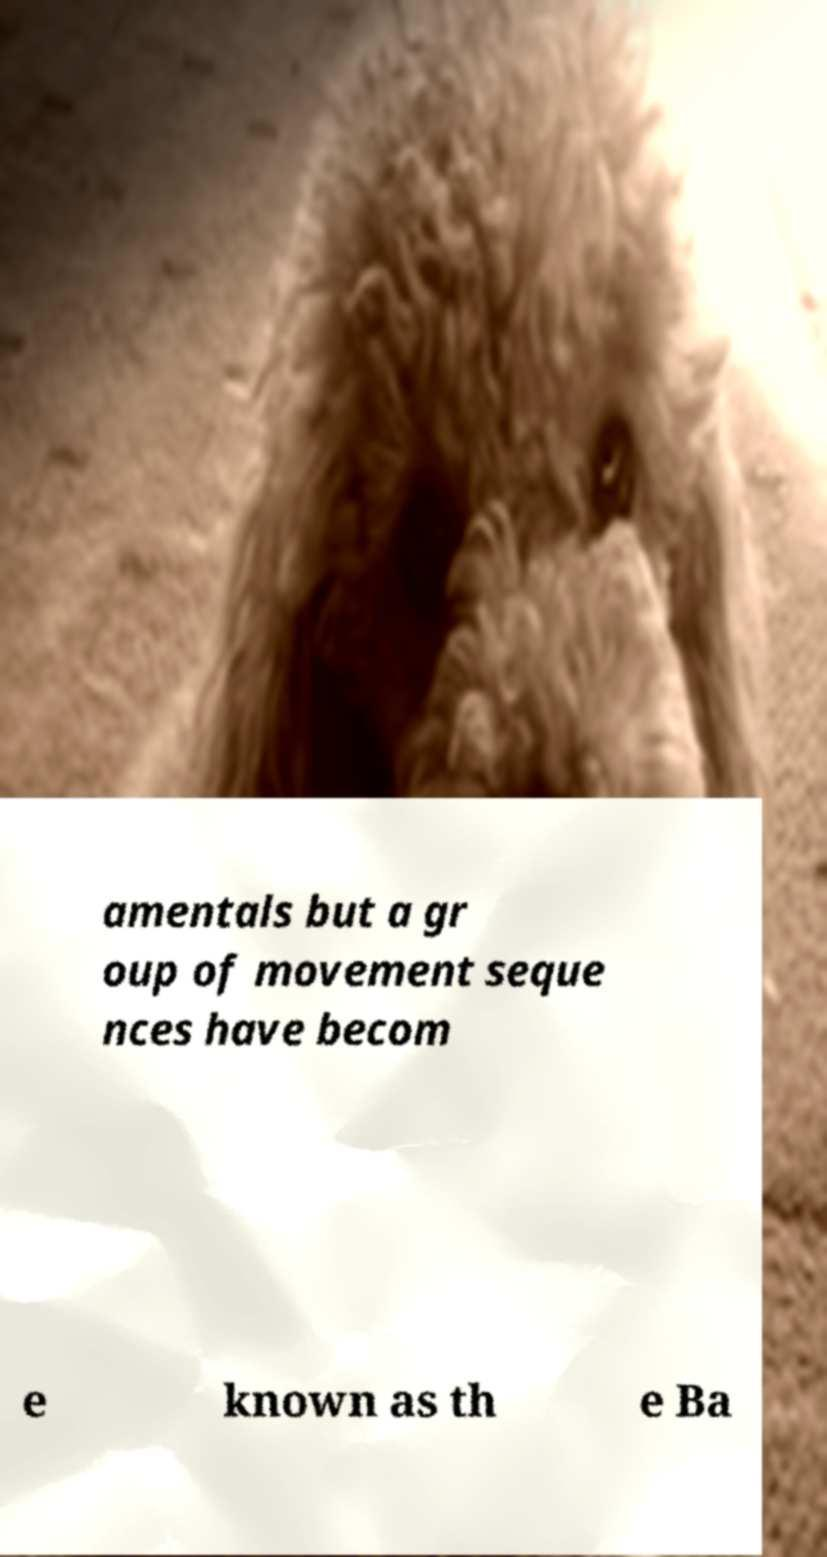There's text embedded in this image that I need extracted. Can you transcribe it verbatim? amentals but a gr oup of movement seque nces have becom e known as th e Ba 